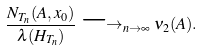<formula> <loc_0><loc_0><loc_500><loc_500>\frac { N _ { T _ { n } } ( A , x _ { 0 } ) } { \lambda ( H _ { T _ { n } } ) } \longrightarrow _ { n \rightarrow \infty } \nu _ { 2 } ( A ) .</formula> 